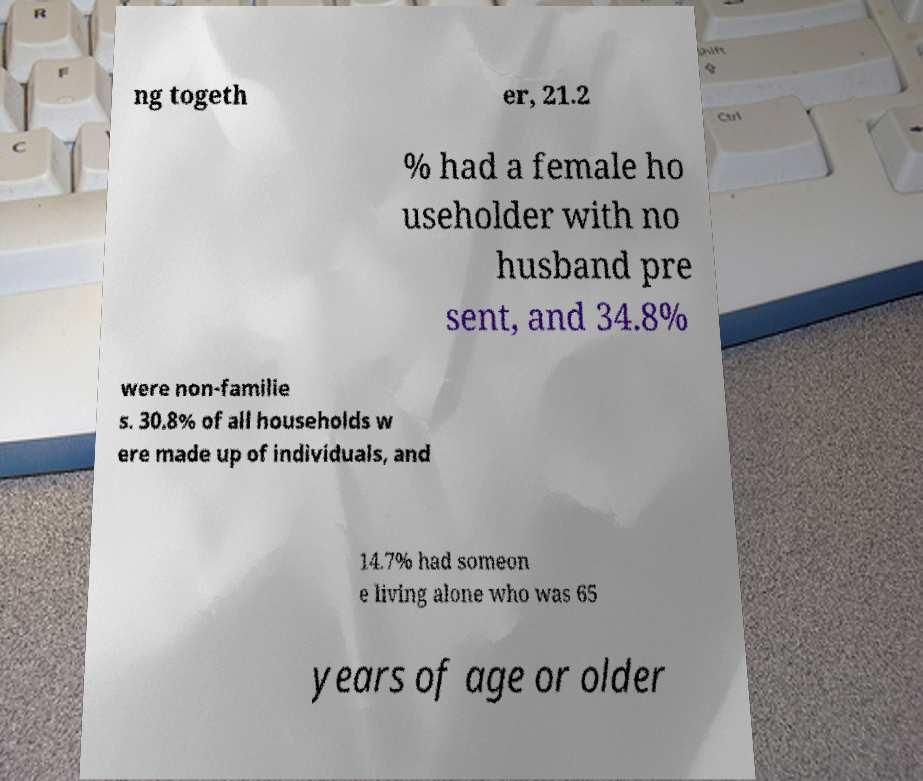Could you extract and type out the text from this image? ng togeth er, 21.2 % had a female ho useholder with no husband pre sent, and 34.8% were non-familie s. 30.8% of all households w ere made up of individuals, and 14.7% had someon e living alone who was 65 years of age or older 